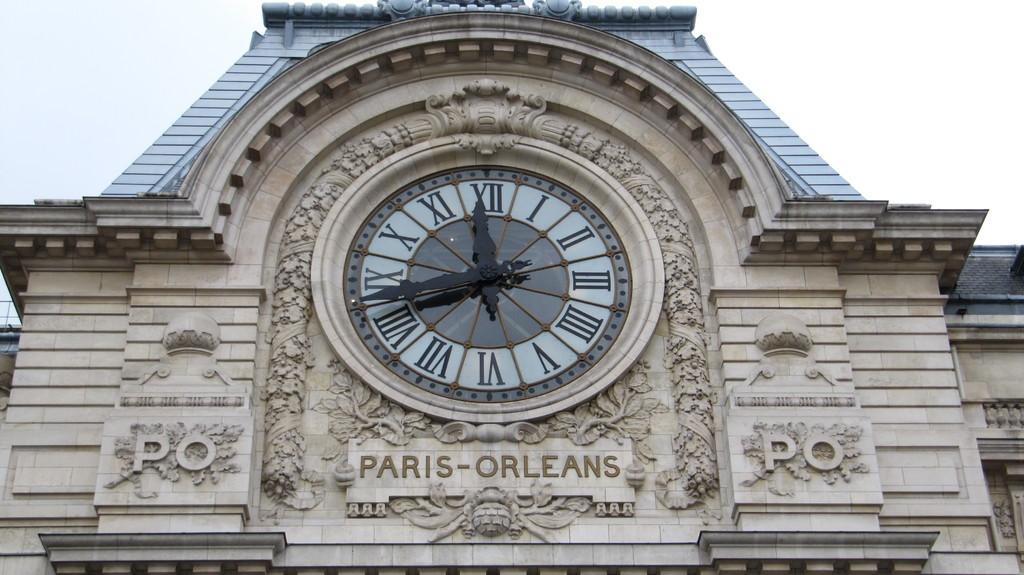<image>
Summarize the visual content of the image. a clock outside with sign for Paris-Orleans has roman numerals 